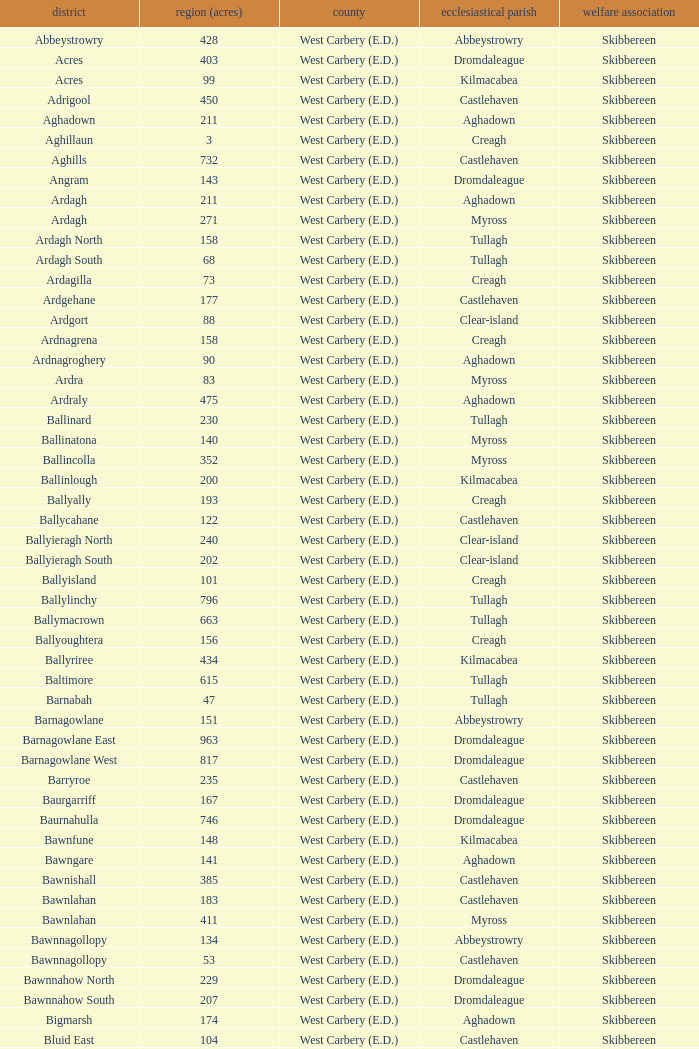What are the Baronies when the area (in acres) is 276? West Carbery (E.D.). 